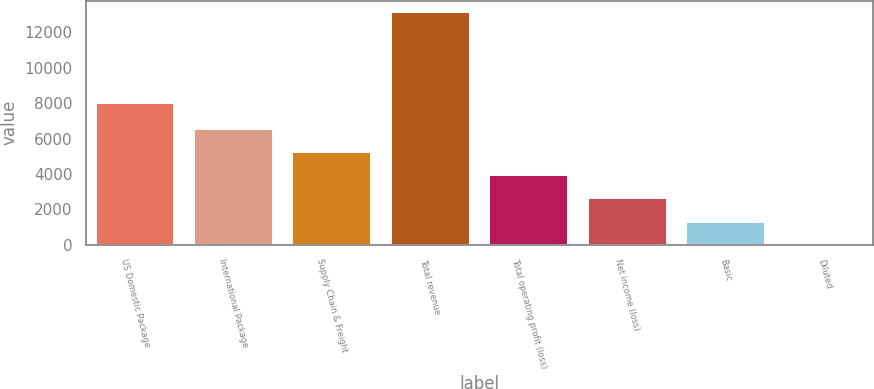Convert chart to OTSL. <chart><loc_0><loc_0><loc_500><loc_500><bar_chart><fcel>US Domestic Package<fcel>International Package<fcel>Supply Chain & Freight<fcel>Total revenue<fcel>Total operating profit (loss)<fcel>Net income (loss)<fcel>Basic<fcel>Diluted<nl><fcel>8004<fcel>6568.5<fcel>5255<fcel>13136<fcel>3941.5<fcel>2628<fcel>1314.5<fcel>1<nl></chart> 